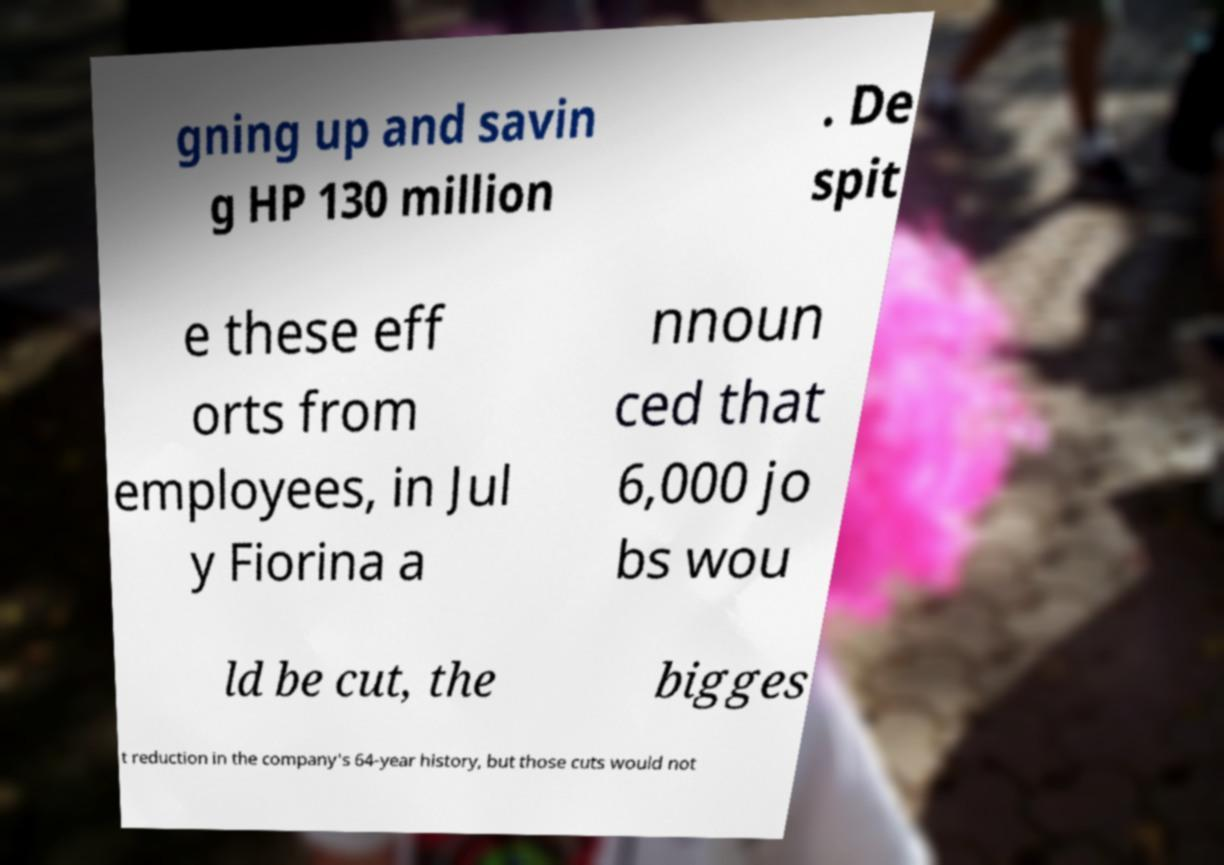I need the written content from this picture converted into text. Can you do that? gning up and savin g HP 130 million . De spit e these eff orts from employees, in Jul y Fiorina a nnoun ced that 6,000 jo bs wou ld be cut, the bigges t reduction in the company's 64-year history, but those cuts would not 